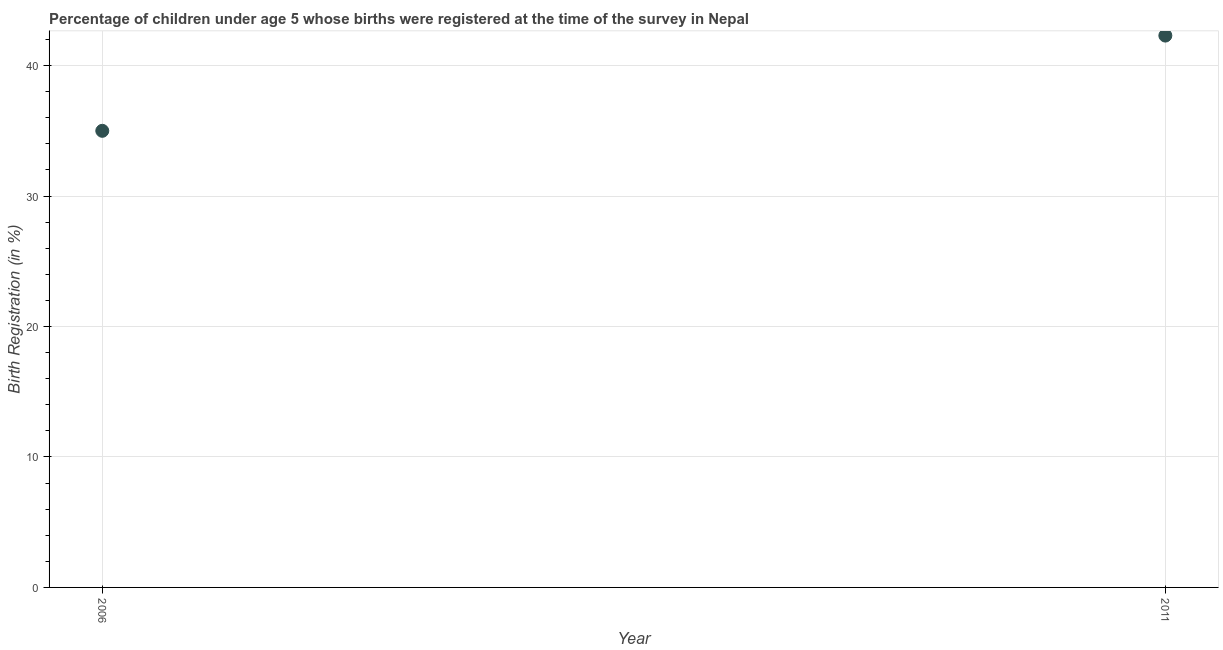What is the birth registration in 2011?
Offer a very short reply. 42.3. Across all years, what is the maximum birth registration?
Offer a very short reply. 42.3. Across all years, what is the minimum birth registration?
Your answer should be compact. 35. In which year was the birth registration maximum?
Offer a very short reply. 2011. What is the sum of the birth registration?
Provide a succinct answer. 77.3. What is the difference between the birth registration in 2006 and 2011?
Offer a terse response. -7.3. What is the average birth registration per year?
Ensure brevity in your answer.  38.65. What is the median birth registration?
Ensure brevity in your answer.  38.65. In how many years, is the birth registration greater than 40 %?
Make the answer very short. 1. Do a majority of the years between 2011 and 2006 (inclusive) have birth registration greater than 30 %?
Give a very brief answer. No. What is the ratio of the birth registration in 2006 to that in 2011?
Offer a terse response. 0.83. In how many years, is the birth registration greater than the average birth registration taken over all years?
Keep it short and to the point. 1. How many years are there in the graph?
Ensure brevity in your answer.  2. Does the graph contain any zero values?
Keep it short and to the point. No. What is the title of the graph?
Your answer should be compact. Percentage of children under age 5 whose births were registered at the time of the survey in Nepal. What is the label or title of the Y-axis?
Offer a terse response. Birth Registration (in %). What is the Birth Registration (in %) in 2006?
Provide a succinct answer. 35. What is the Birth Registration (in %) in 2011?
Offer a terse response. 42.3. What is the ratio of the Birth Registration (in %) in 2006 to that in 2011?
Ensure brevity in your answer.  0.83. 